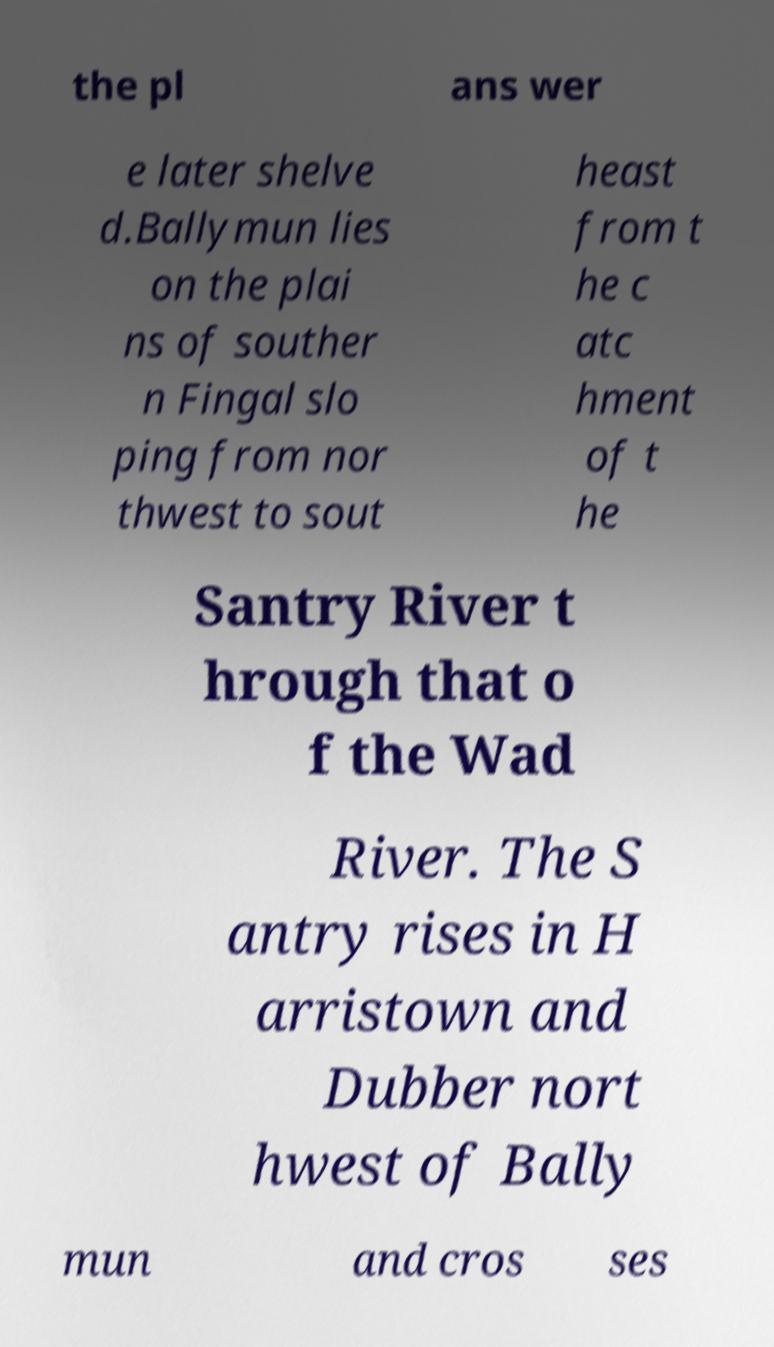Can you read and provide the text displayed in the image?This photo seems to have some interesting text. Can you extract and type it out for me? the pl ans wer e later shelve d.Ballymun lies on the plai ns of souther n Fingal slo ping from nor thwest to sout heast from t he c atc hment of t he Santry River t hrough that o f the Wad River. The S antry rises in H arristown and Dubber nort hwest of Bally mun and cros ses 